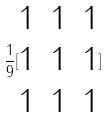<formula> <loc_0><loc_0><loc_500><loc_500>\frac { 1 } { 9 } [ \begin{matrix} 1 & 1 & 1 \\ 1 & 1 & 1 \\ 1 & 1 & 1 \end{matrix} ]</formula> 